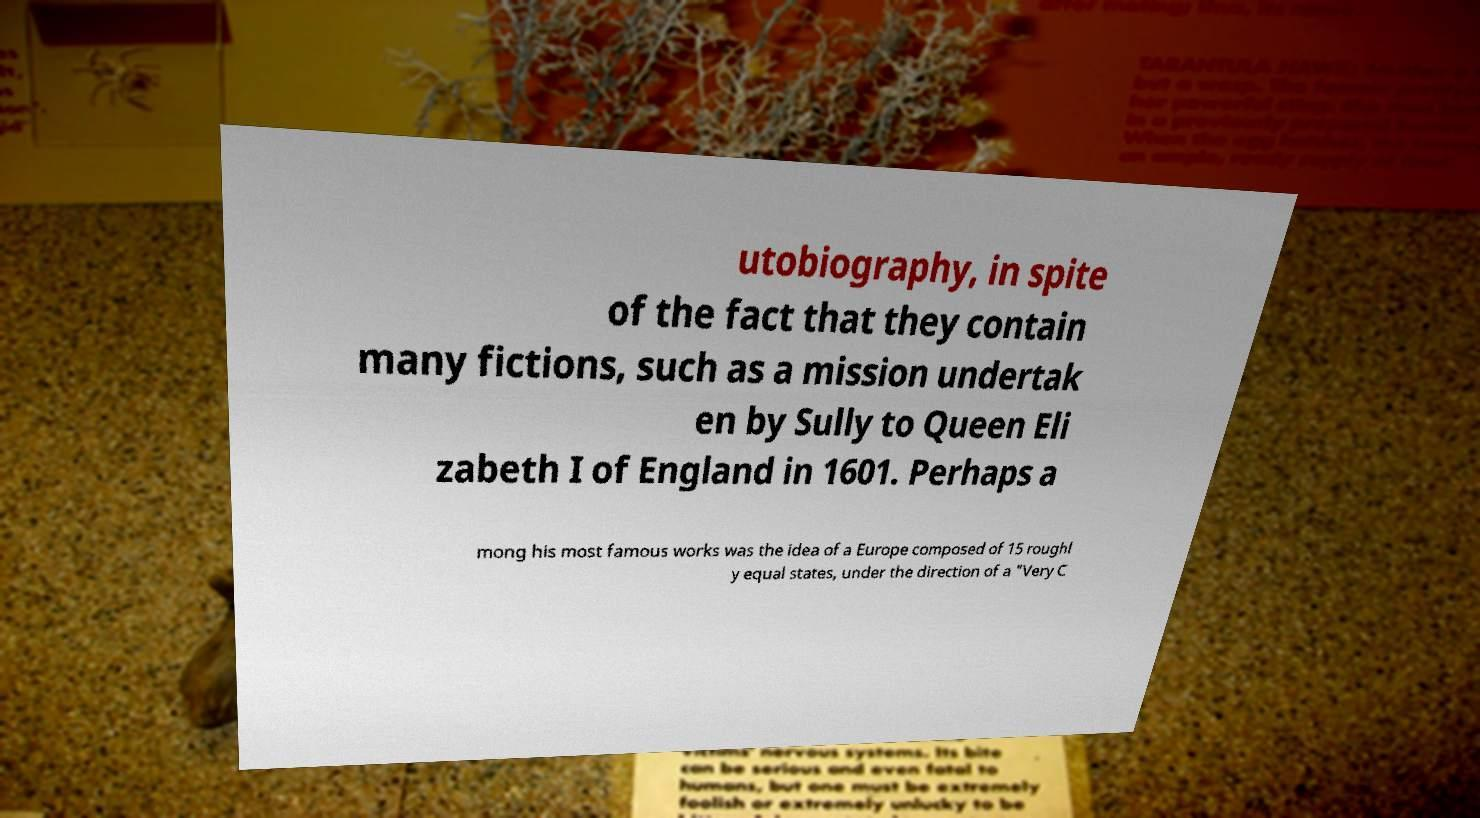Could you assist in decoding the text presented in this image and type it out clearly? utobiography, in spite of the fact that they contain many fictions, such as a mission undertak en by Sully to Queen Eli zabeth I of England in 1601. Perhaps a mong his most famous works was the idea of a Europe composed of 15 roughl y equal states, under the direction of a "Very C 